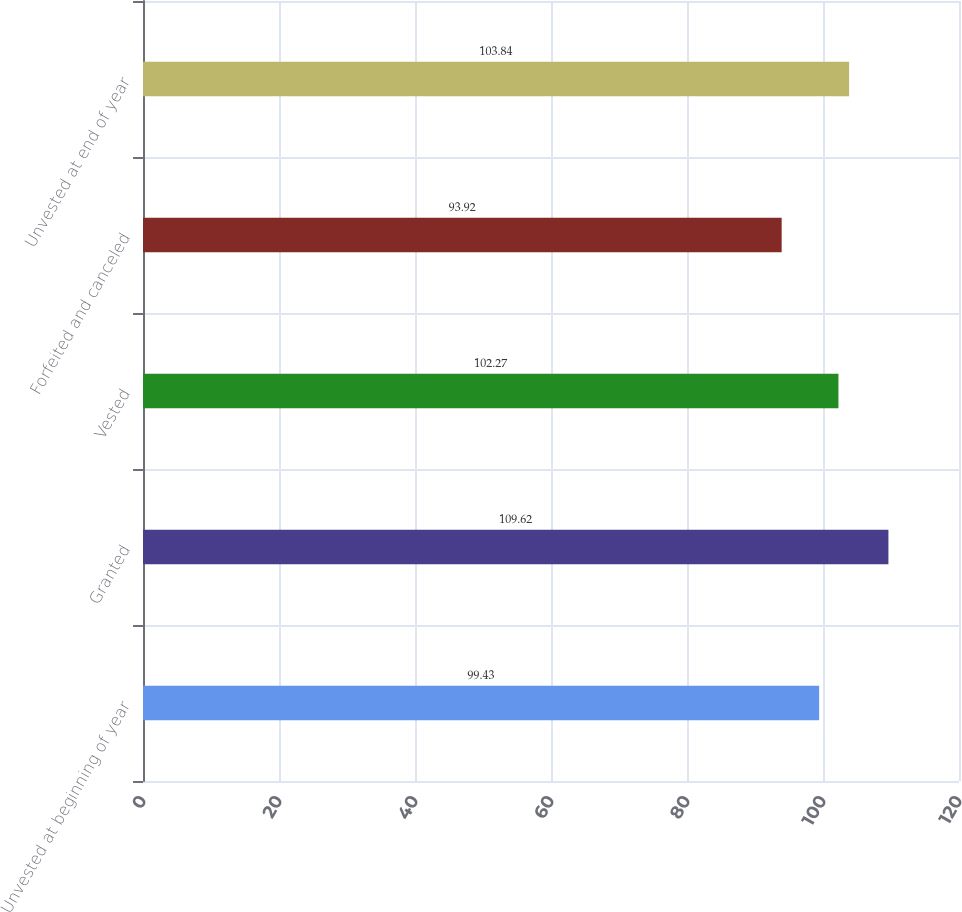Convert chart. <chart><loc_0><loc_0><loc_500><loc_500><bar_chart><fcel>Unvested at beginning of year<fcel>Granted<fcel>Vested<fcel>Forfeited and canceled<fcel>Unvested at end of year<nl><fcel>99.43<fcel>109.62<fcel>102.27<fcel>93.92<fcel>103.84<nl></chart> 